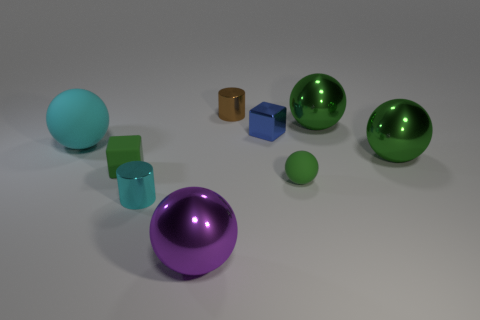Subtract all brown cylinders. How many green spheres are left? 3 Subtract all purple balls. How many balls are left? 4 Subtract all small green balls. How many balls are left? 4 Subtract 1 spheres. How many spheres are left? 4 Subtract all yellow spheres. Subtract all green blocks. How many spheres are left? 5 Add 1 red cubes. How many objects exist? 10 Subtract all blocks. How many objects are left? 7 Subtract all small brown matte cylinders. Subtract all brown metallic cylinders. How many objects are left? 8 Add 5 spheres. How many spheres are left? 10 Add 7 purple objects. How many purple objects exist? 8 